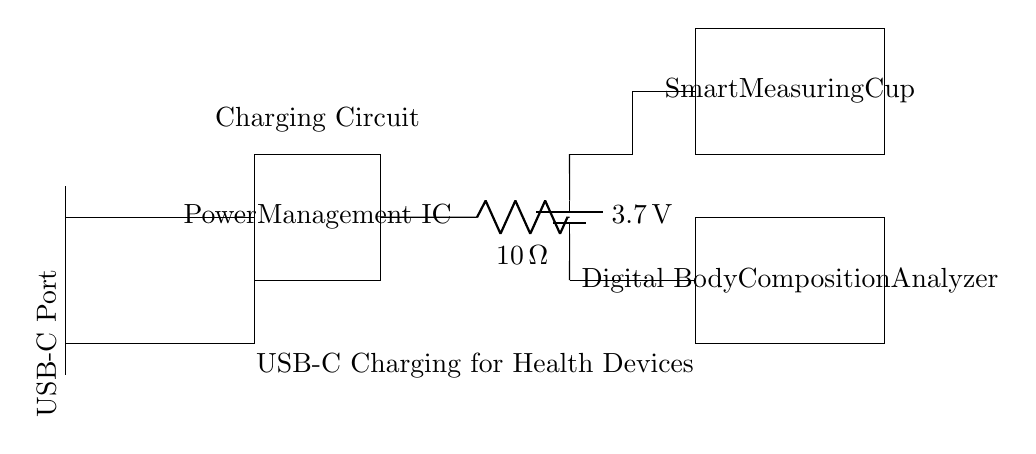what is the voltage of the battery? The voltage marked on the battery in the circuit is 3.7 volts, which indicates the nominal voltage typically produced by Lithium-ion batteries used for charging circuits.
Answer: 3.7 volts what component is used for power regulation? The circuit diagram labels a component as "Power Management IC," which is responsible for regulating the power flow from the USB-C port to the connected devices.
Answer: Power Management IC what resistance value is present in this circuit? The circuit features a resistor labeled as 10 ohms, which is indicated next to the symbol for the resistor in the diagram.
Answer: 10 ohms how many devices are connected to the battery? The circuit diagram shows two devices: one labeled "Digital Body Composition Analyzer" and the other "Smart Measuring Cup," which are both powered by the battery through the power management IC.
Answer: Two what is the purpose of the USB-C port in this circuit? The USB-C port serves as the input for power in the circuit, allowing the battery to be charged and supplying power to the Power Management IC, which distributes the power to the connected devices.
Answer: Charging input explain how the current flows from the USB-C port to the devices. Current flows from the USB-C port into the Power Management IC. From there, current flows to the battery which stores energy. The IC then regulates and distributes the power to the two devices: the Digital Body Composition Analyzer and the Smart Measuring Cup, ensuring they receive the appropriate voltage and current for operation.
Answer: Through the Power Management IC to the devices what is the charging method used for the devices? The circuit uses a direct charging method through the USB-C port, where the external power supply charges the battery while simultaneously powering the devices via the power management IC.
Answer: Direct charging through USB-C 